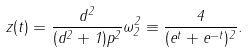<formula> <loc_0><loc_0><loc_500><loc_500>z ( t ) = \frac { d ^ { 2 } } { ( d ^ { 2 } + 1 ) p ^ { 2 } } \omega _ { 2 } ^ { 2 } \equiv \frac { 4 } { ( e ^ { t } + e ^ { - t } ) ^ { 2 } } .</formula> 